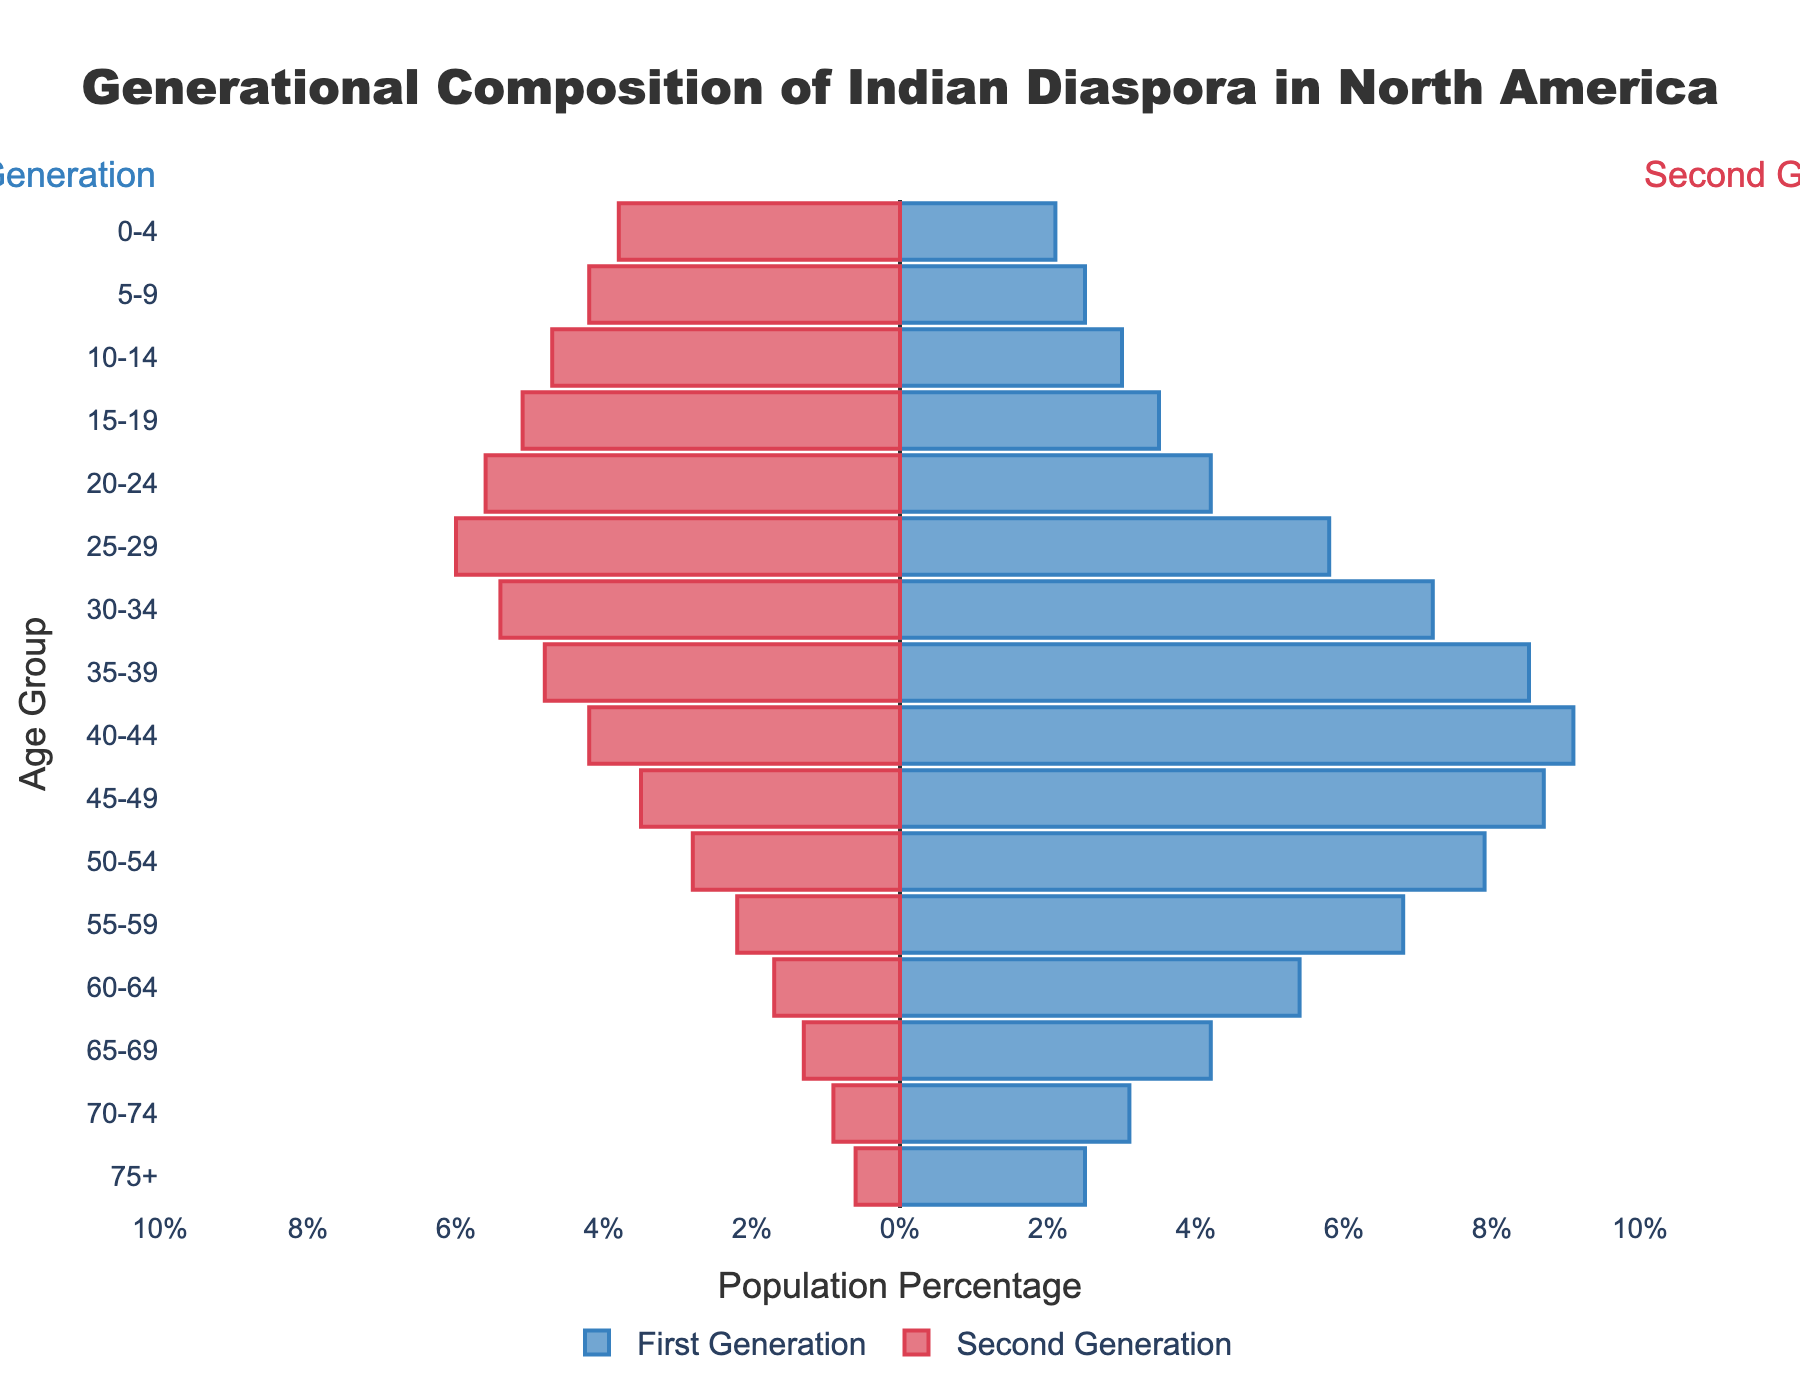How many age groups are plotted in the figure? The data includes age ranges from '0-4' to '75+' which corresponds to a total of 16 distinct age groups.
Answer: 16 What is the title of the figure? The title is displayed at the top of the figure.
Answer: Generational Composition of Indian Diaspora in North America Which age group has the highest population percentage in the first generation? By observing the bar lengths for each age group in the first generation, the '40-44' age group has the longest bar, indicating the highest population percentage of 9.1%.
Answer: 40-44 What age group has the highest population percentage in the second generation? In the second generation, the '25-29' age group has the longest negative bar, indicating the highest population percentage of 6.0%.
Answer: 25-29 How does the population percentage of the '30-34' age group compare between the first and second generations? For the '30-34' age group, the first generation has a population percentage of 7.2% whereas the second generation has 5.4%.
Answer: 7.2% vs 5.4% Which generation has a larger population percentage in the '75+' age group? The first generation has a larger population percentage (2.5%) compared to the second generation (0.6%) in the '75+' age group.
Answer: First generation What is the combined population percentage for the '10-14' and '15-19' age groups in the second generation? The percentages for '10-14' and '15-19' in the second generation are 4.7% and 5.1%, respectively. Adding these together gives a combined percentage of 4.7 + 5.1 = 9.8%.
Answer: 9.8% What is the difference in population percentage between the '45-49' age group in the first and second generations? The '45-49' age group percentages for the first and second generations are 8.7% and 3.5%, respectively. The difference is 8.7 - 3.5 = 5.2%.
Answer: 5.2% Which age group shows the largest discrepancy in population percentage between the two generations? Among all age groups, '40-44' shows the largest difference in population percentage with 9.1% for the first generation and 4.2% for the second generation, resulting in a discrepancy of 9.1 - 4.2 = 4.9%.
Answer: 40-44 How does the population percentage for the '55-59' age group in the first generation compare to the '60-64' age group in the second generation? The first generation '55-59' age group has a population percentage of 6.8%, while the second generation '60-64' age group has a percentage of 1.7%. Therefore, 6.8% is much higher than 1.7%.
Answer: Much higher 